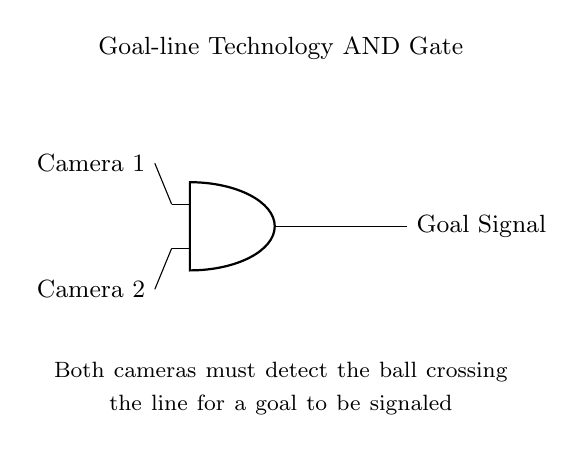What are the inputs to the AND gate? The inputs are labeled as Camera 1 and Camera 2, indicating the detection from two different cameras.
Answer: Camera 1, Camera 2 What happens when only one camera detects the ball? The output of the AND gate will be low (no goal signal) because the condition requires both inputs to be high.
Answer: No goal signal What is the output of the AND gate called? The output wire is labeled "Goal Signal," representing the indication of a goal when the conditions are met.
Answer: Goal Signal How many inputs does the AND gate have? An AND gate has two inputs, as shown in the diagram.
Answer: Two What is required for the output signal to indicate a goal? Both camera inputs need to detect the ball crossing the line for a goal signal to be produced.
Answer: Both cameras detect the ball What logic operation does this circuit perform? The circuit performs a logical AND operation, meaning the output is true only if all inputs are true.
Answer: AND operation 